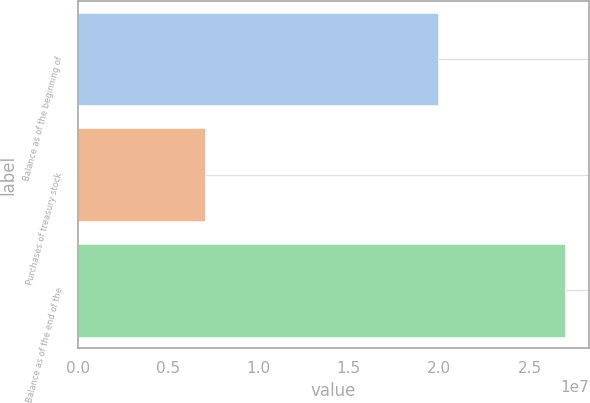<chart> <loc_0><loc_0><loc_500><loc_500><bar_chart><fcel>Balance as of the beginning of<fcel>Purchases of treasury stock<fcel>Balance as of the end of the<nl><fcel>1.99165e+07<fcel>7.03442e+06<fcel>2.69509e+07<nl></chart> 